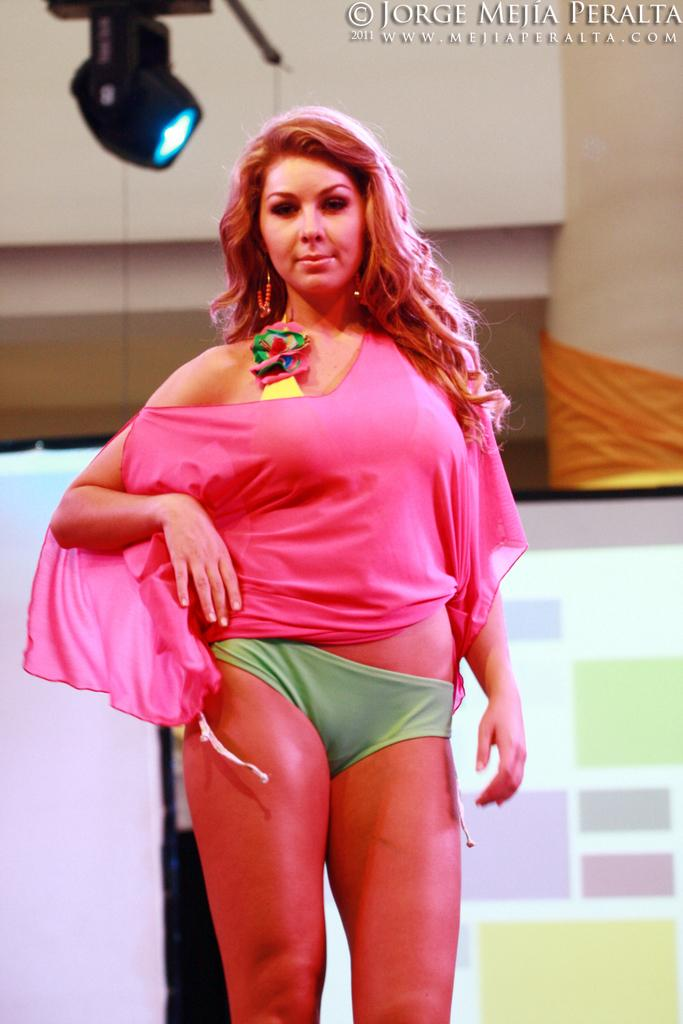What is the main subject of the image? There is a woman standing in the image. What is the woman doing in the image? The woman is giving a pose for the picture. What can be seen in the background of the image? There is a board and a wall in the background of the image. What is visible at the top of the image? There is a light and some text at the top of the image. What is the weather like in the image? The provided facts do not mention any information about the weather, so it cannot be determined from the image. How does the woman's stomach feel in the image? There is no information about the woman's stomach or any emotions she might be feeling, so it cannot be determined from the image. 